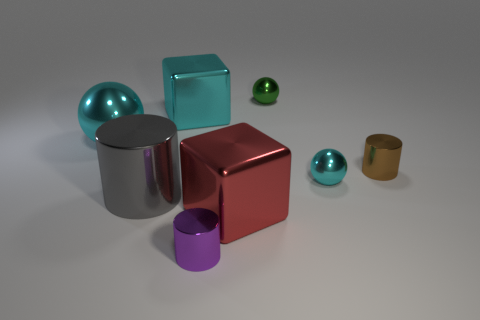Is there a brown cylinder that is left of the cyan metallic ball behind the brown shiny cylinder?
Your answer should be very brief. No. Are there any tiny brown metallic cylinders on the left side of the tiny green metallic object?
Keep it short and to the point. No. There is a big cyan metallic thing that is in front of the cyan metallic block; does it have the same shape as the tiny cyan thing?
Your answer should be very brief. Yes. How many small cyan objects are the same shape as the brown object?
Offer a very short reply. 0. Is there a large gray thing that has the same material as the large cylinder?
Keep it short and to the point. No. There is a large block that is to the left of the big thing that is on the right side of the large cyan metal cube; what is it made of?
Make the answer very short. Metal. What is the size of the ball right of the small green ball?
Your answer should be compact. Small. Do the large metallic ball and the large cube that is behind the large cylinder have the same color?
Make the answer very short. Yes. Are there any tiny metal spheres of the same color as the big metallic ball?
Give a very brief answer. Yes. What number of big objects are cubes or cyan metal objects?
Provide a succinct answer. 3. 